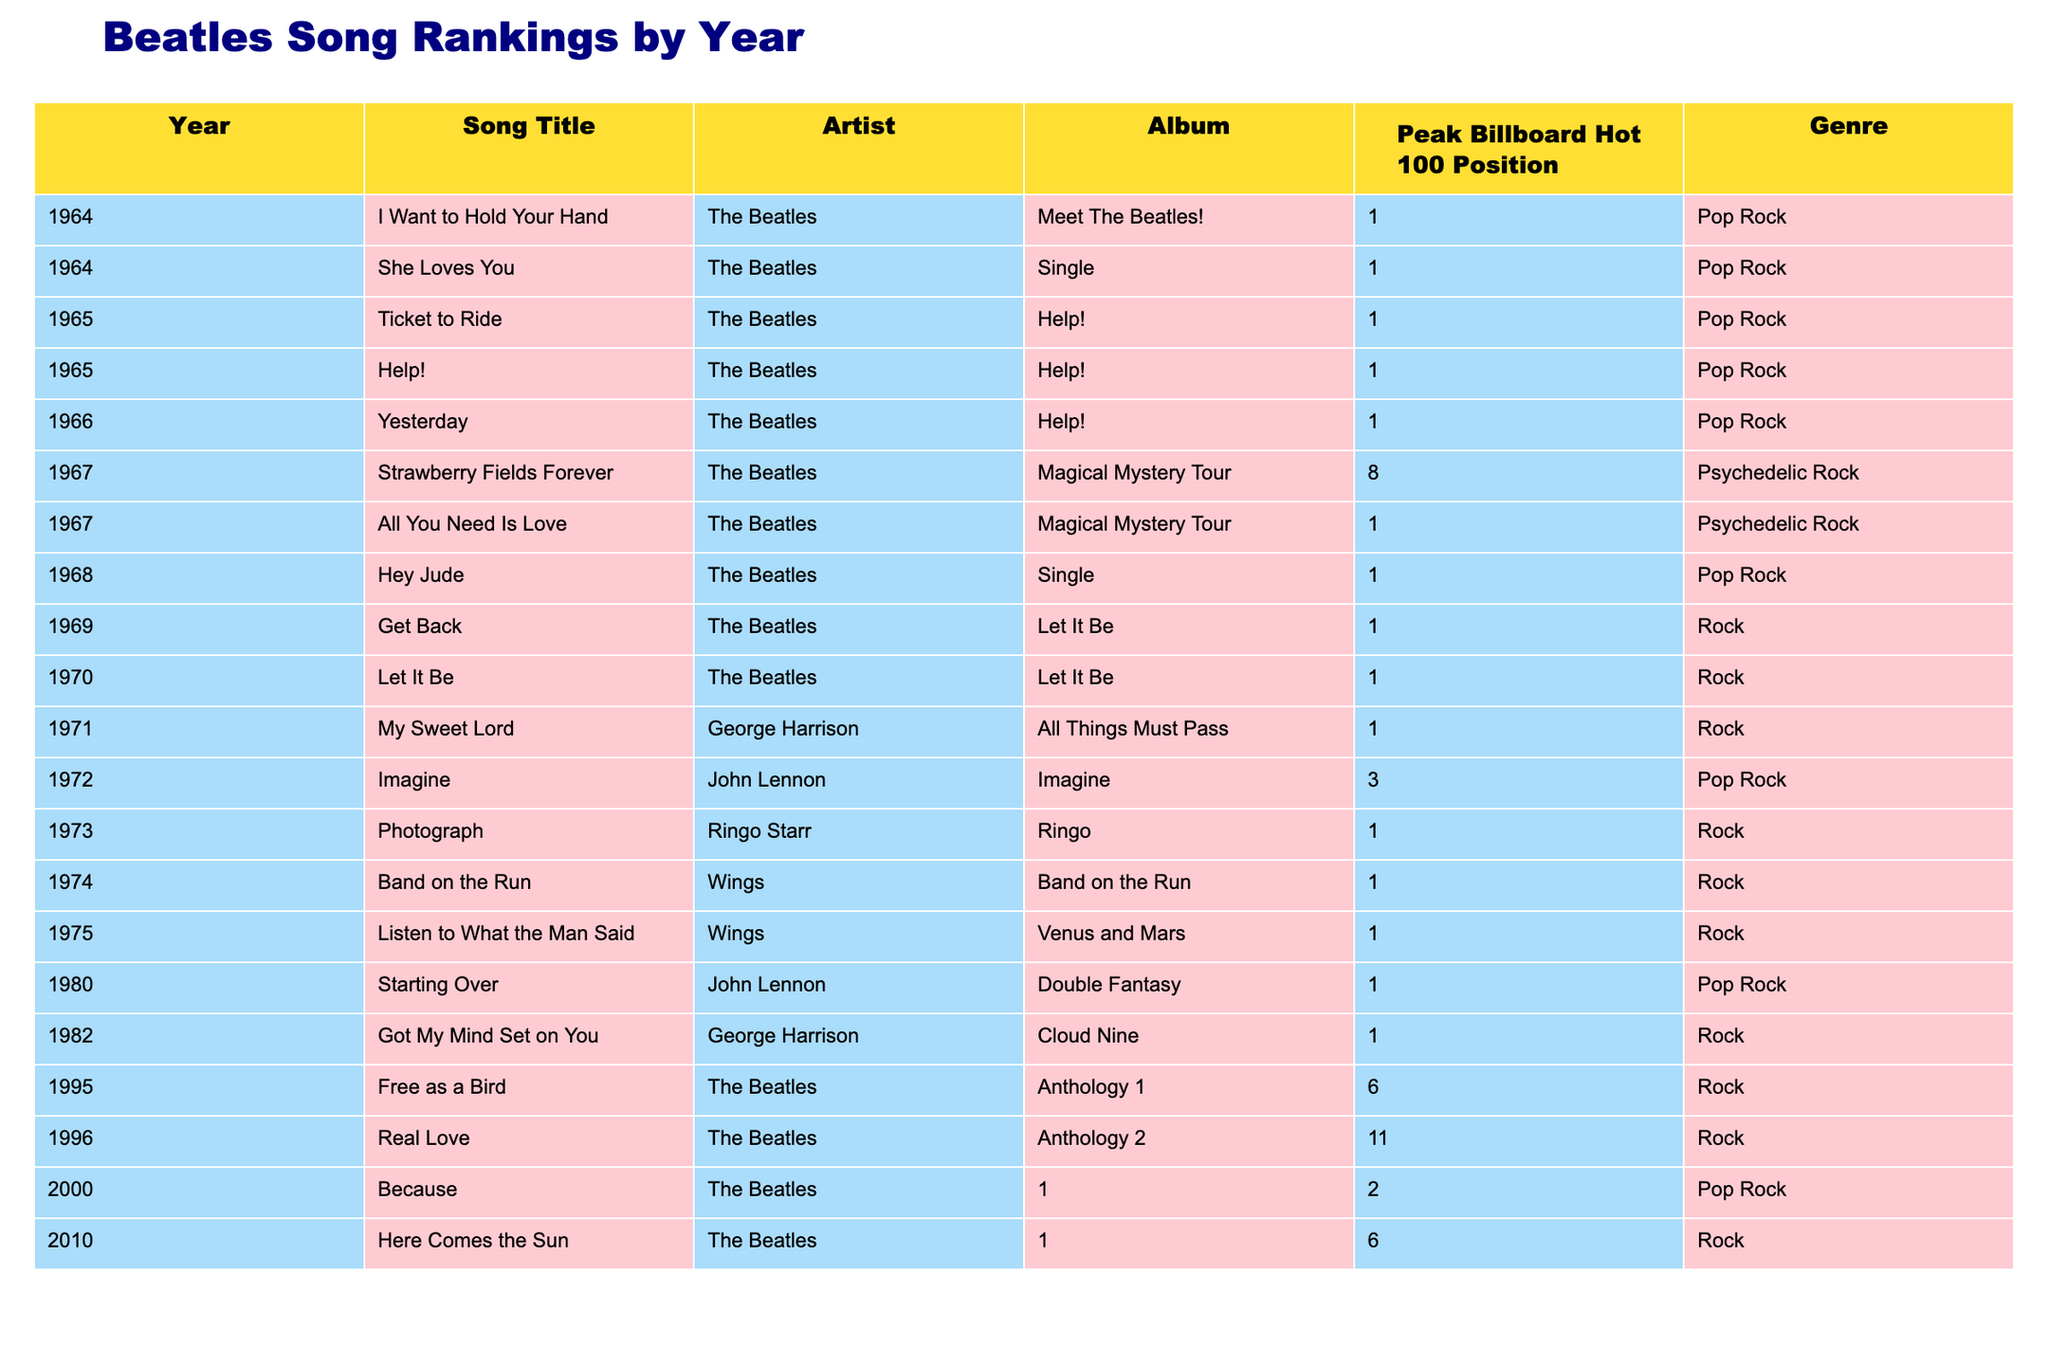What is the highest peak position achieved by a Beatles song in the 1960s? The highest peak position for Beatles songs in the 1960s is 1, as several songs reached this position in various years, including "I Want to Hold Your Hand," "She Loves You," "Ticket to Ride," "Help!," "Yesterday," and "All You Need Is Love."
Answer: 1 Which Beatles song reached number 1 in 1970? The song "Let It Be" by The Beatles reached number 1 in 1970, according to the table.
Answer: Let It Be How many Beatles songs peaked at number 1 from 1964 to 1975? By counting the entries in the table for songs that reached number 1 from 1964 to 1975, there are 10 songs listed.
Answer: 10 Did any Beatles songs peak at number 1 in the 1980s? Looking at the table, the only Beatles song that peaked at number 1 in the 1980s is "Starting Over" by John Lennon in 1980, which confirms the statement.
Answer: Yes Which Beatles album had the most songs that reached number 1? The album "Help!" contains a total of three songs that peaked at number 1 ("Ticket to Ride," "Help!," and "Yesterday"), making it the album with the most number 1 songs.
Answer: Help! What is the average peak position of Beatles songs released between 1964 and 1975? To find the average, we add the peak positions of all songs from 1964 to 1975 that reached number 1 (which total 10) and include the other songs' positions, then divide by the total number of these songs. The sum of the peak positions is 1 (ten times) and additional songs which brings the total songs to 13 evaluated. The total, including others is 1*10 + 2 + 3 = 15, divided by 13 gives approximately 1.15.
Answer: 1.15 Which song had the highest peak position in the 1990s? In the 1990s, "Free as a Bird" peaked at position 6, which is the highest position compared to "Real Love," which peaked at 11. Thus, "Free as a Bird" had the highest peak.
Answer: Free as a Bird How many songs did George Harrison have that reached number 1? According to the table, George Harrison has two songs that peaked at number 1: "My Sweet Lord" and "Got My Mind Set on You."
Answer: 2 What genre primarily dominates the Beatles songs listed in the table? The dominant genre in the songs listed is "Pop Rock," which appears frequently among the entries for their popular songs.
Answer: Pop Rock Is "Strawberry Fields Forever" the only Beatles song to peak in the top 10 but not at number 1? Based on the table, "Strawberry Fields Forever" peaked at position 8, and all other mentioned songs either peaked at 1 or had numbers lower than 1, making it unique for not reaching number 1 within the listed songs.
Answer: Yes What year did Wings release their song that peaked at number 1? According to the table, Wings released "Band on the Run," which peaked at number 1 in 1974.
Answer: 1974 